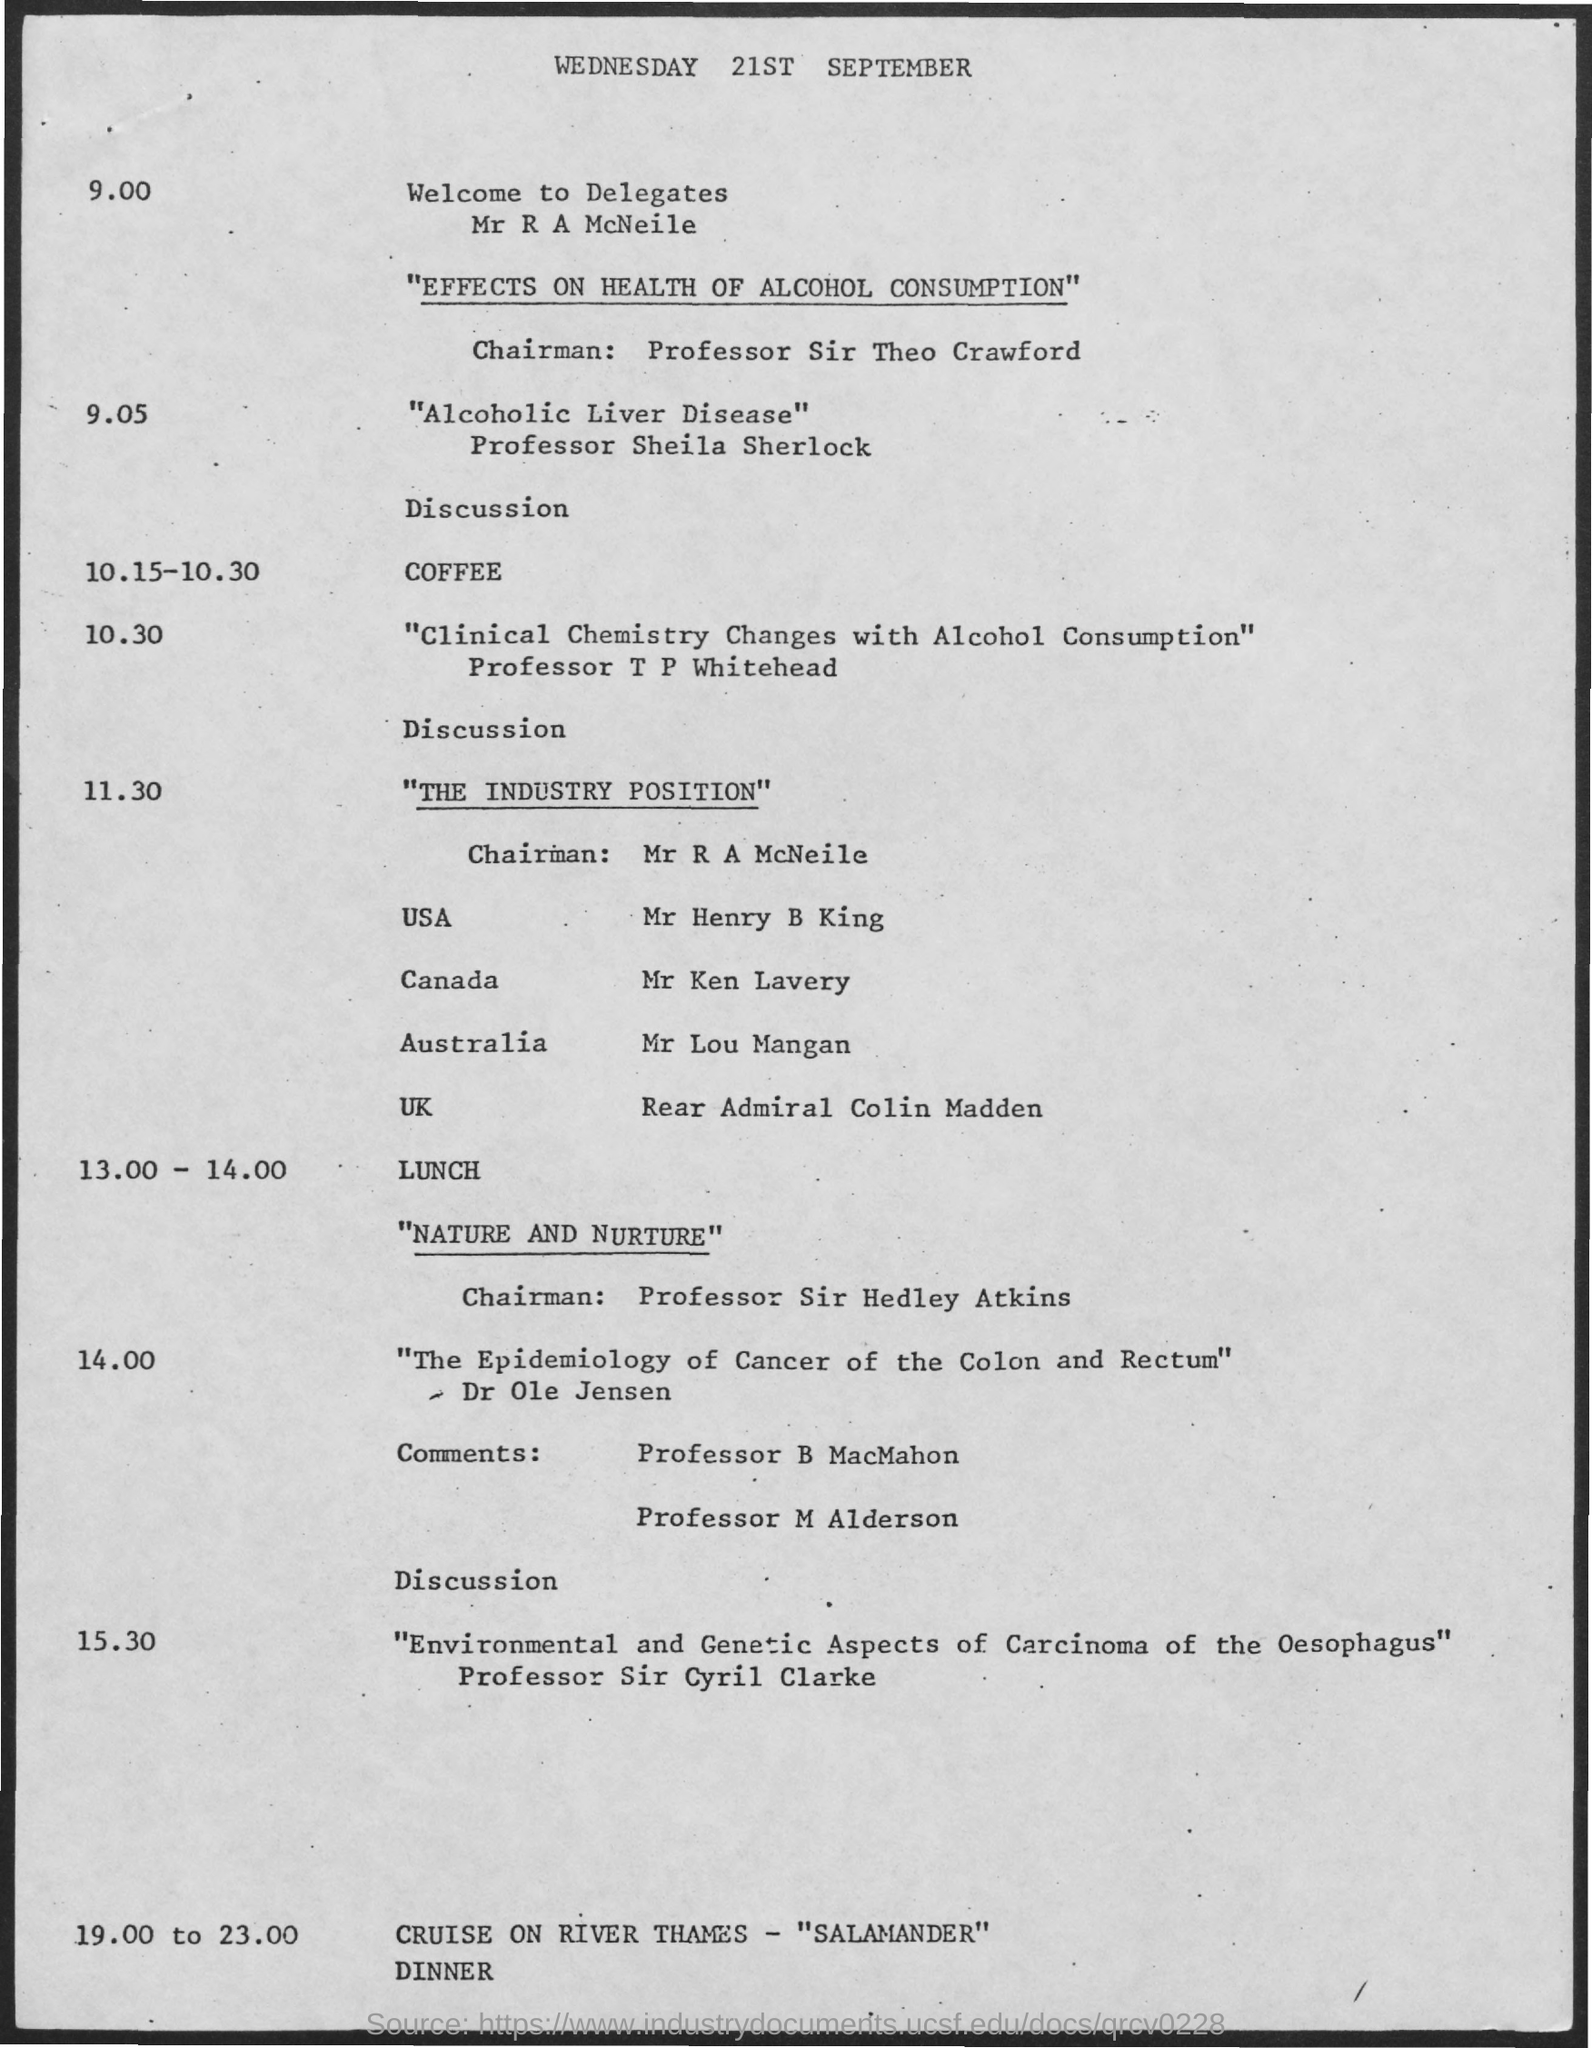What is the date mentioned in the document?
Keep it short and to the point. Wednesday 21st september. 